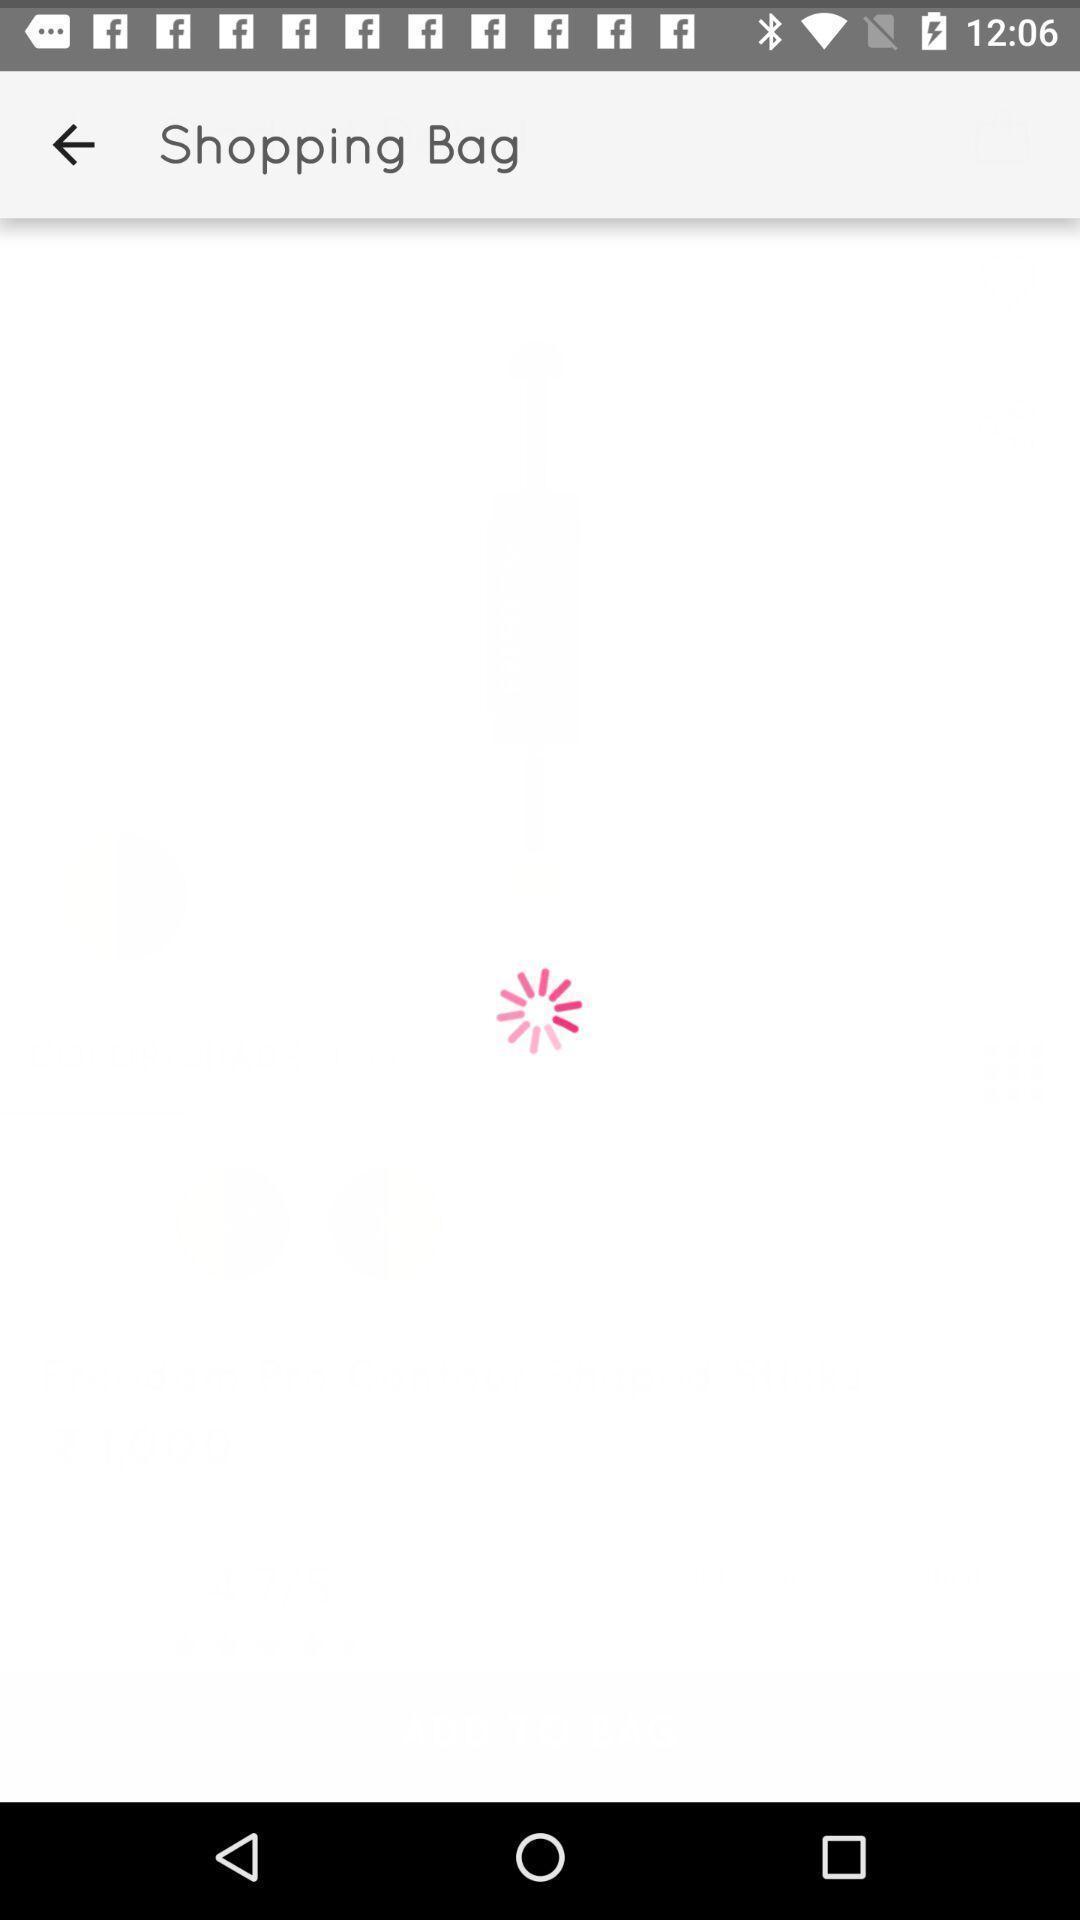Describe the visual elements of this screenshot. Shopping app displayed loading page of shopping bag. 